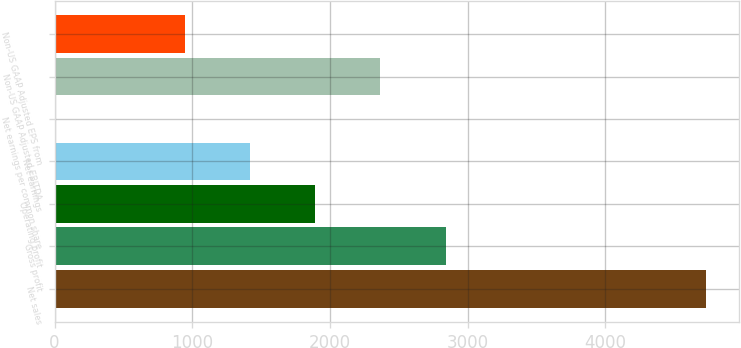Convert chart to OTSL. <chart><loc_0><loc_0><loc_500><loc_500><bar_chart><fcel>Net sales<fcel>Gross profit<fcel>Operating profit<fcel>Net earnings<fcel>Net earnings per common share<fcel>Non-US GAAP Adjusted EBITDA<fcel>Non-US GAAP Adjusted EPS from<nl><fcel>4732.7<fcel>2840.1<fcel>1893.8<fcel>1420.65<fcel>1.2<fcel>2366.95<fcel>947.5<nl></chart> 